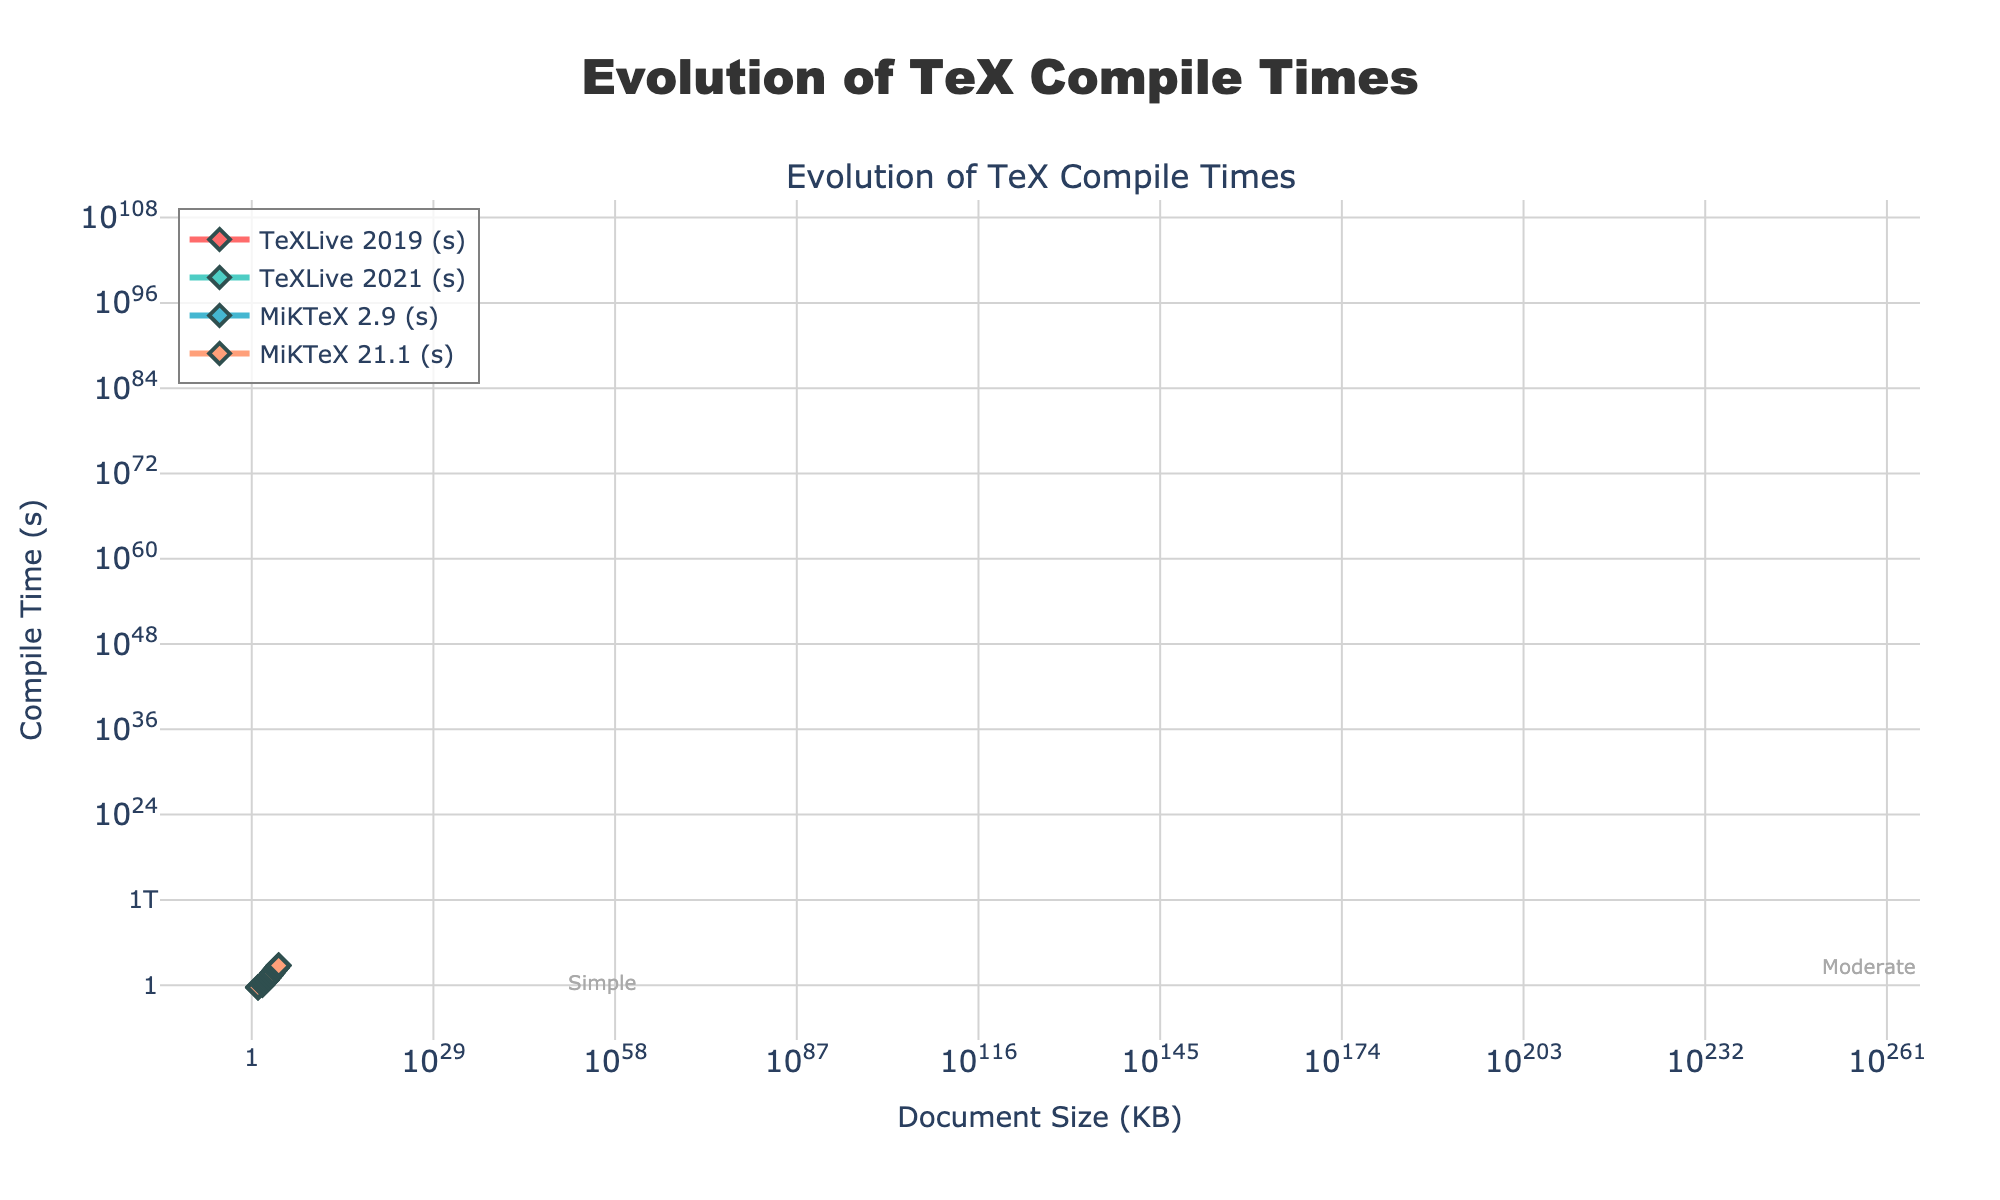What's the average compile time for a 10000 KB document across all TeX distributions? First, identify the compile times for a 10000 KB document from the figure: TeXLive 2019 (298.5s), TeXLive 2021 (247.9s), MiKTeX 2.9 (328.4s), and MiKTeX 21.1 (277.3s). Sum these values: 298.5 + 247.9 + 328.4 + 277.3 = 1152.1. Divide by the number of distributions (4): 1152.1 / 4 = 288.03
Answer: 288.03 Which TeX distribution has the fastest compile time for a 5000 KB document? Look at the compile times for a 5000 KB document among all distributions: TeXLive 2019 (142.8s), TeXLive 2021 (118.5s), MiKTeX 2.9 (157.1s), and MiKTeX 21.1 (132.6s). The smallest value is 118.5s for TeXLive 2021
Answer: TeXLive 2021 In general, how does the compile time trend change as document size increases? Examine the line plots for all distributions. All lines show an increasing trend in compile time as document size increases, indicating that larger documents take longer to compile
Answer: Increases How much faster is the compile time for a 2000 KB document in TeXLive 2021 compared to TeXLive 2019? Find the compile times for a 2000 KB document: TeXLive 2021 (45.3s) and TeXLive 2019 (54.6s). Subtract the time for TeXLive 2021 from TeXLive 2019: 54.6 - 45.3 = 9.3
Answer: 9.3 seconds Which complexity level has the highest annotated y-position on the plot? Visually inspect the annotations for complexity levels on the chart. The "Extremely Complex" annotation appears at the highest position
Answer: Extremely Complex What is the compile time difference between MiKTeX 2.9 and MiKTeX 21.1 for a 500 KB document? Locate the compile times for a 500 KB document: MiKTeX 2.9 (13.5s) and MiKTeX 21.1 (11.4s). Subtract the time for MiKTeX 21.1 from MiKTeX 2.9: 13.5 - 11.4 = 2.1
Answer: 2.1 seconds Is the improvement from TeXLive 2019 to TeXLive 2021 consistent across all document sizes? Compare the compile times for TeXLive 2019 and TeXLive 2021 at each document size. In each case, TeXLive 2021 has a smaller compile time, indicating a consistent improvement
Answer: Yes What is the ratio of compile time for TeXLive 2021 compared to MiKTeX 2.9 for a 50 KB document? Find the compile times for a 50 KB document: TeXLive 2021 (1.0s) and MiKTeX 2.9 (1.4s). Divide the time for TeXLive 2021 by MiKTeX 2.9: 1.0 / 1.4 ≈ 0.714
Answer: 0.714 